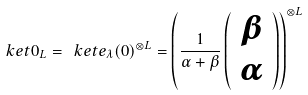<formula> <loc_0><loc_0><loc_500><loc_500>\ k e t { 0 } _ { L } = \ k e t { e _ { \lambda } ( 0 ) } ^ { \otimes L } = \left ( \frac { 1 } { \alpha + \beta } \left ( \begin{array} { c } \beta \\ \alpha \end{array} \right ) \right ) ^ { \otimes L }</formula> 